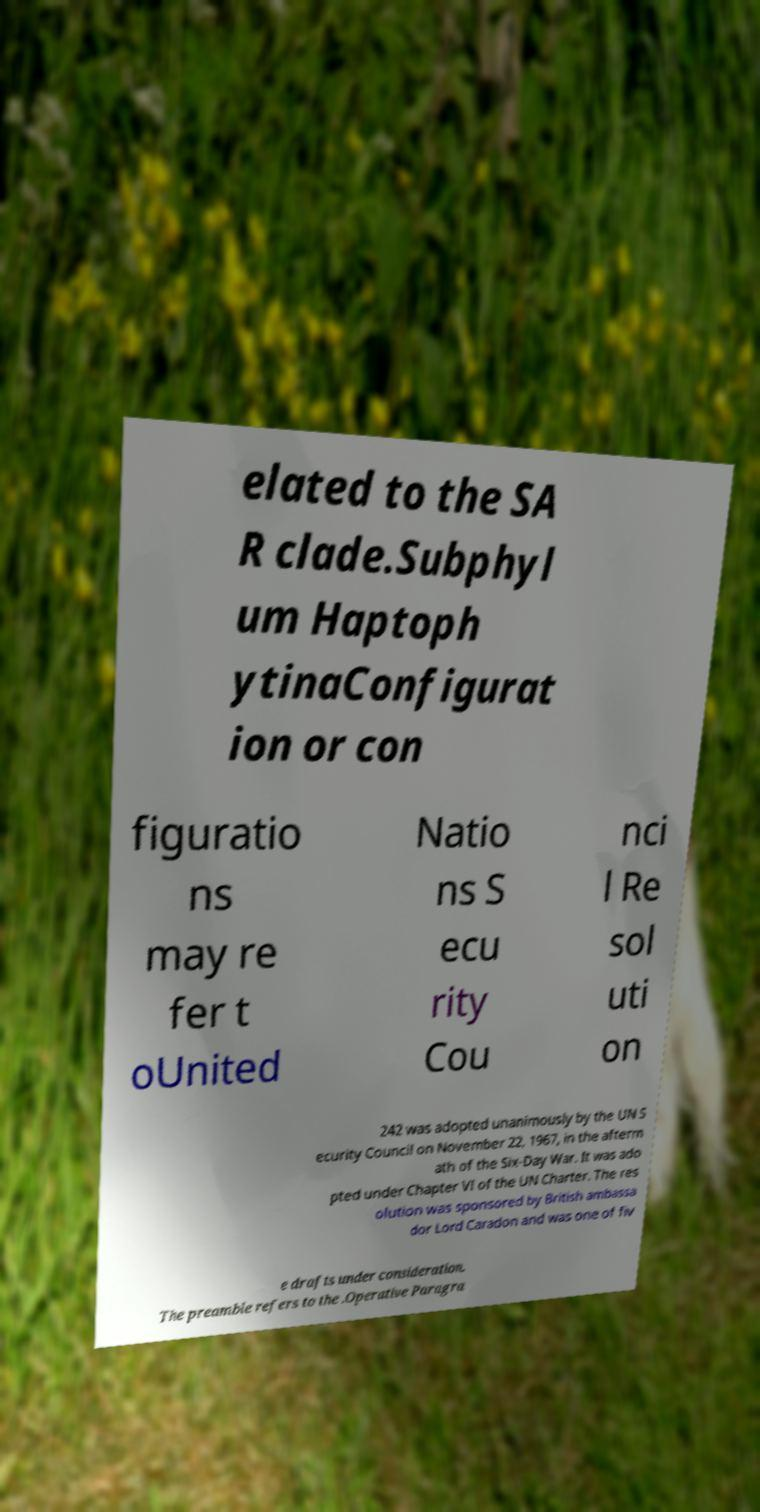What messages or text are displayed in this image? I need them in a readable, typed format. elated to the SA R clade.Subphyl um Haptoph ytinaConfigurat ion or con figuratio ns may re fer t oUnited Natio ns S ecu rity Cou nci l Re sol uti on 242 was adopted unanimously by the UN S ecurity Council on November 22, 1967, in the afterm ath of the Six-Day War. It was ado pted under Chapter VI of the UN Charter. The res olution was sponsored by British ambassa dor Lord Caradon and was one of fiv e drafts under consideration. The preamble refers to the .Operative Paragra 